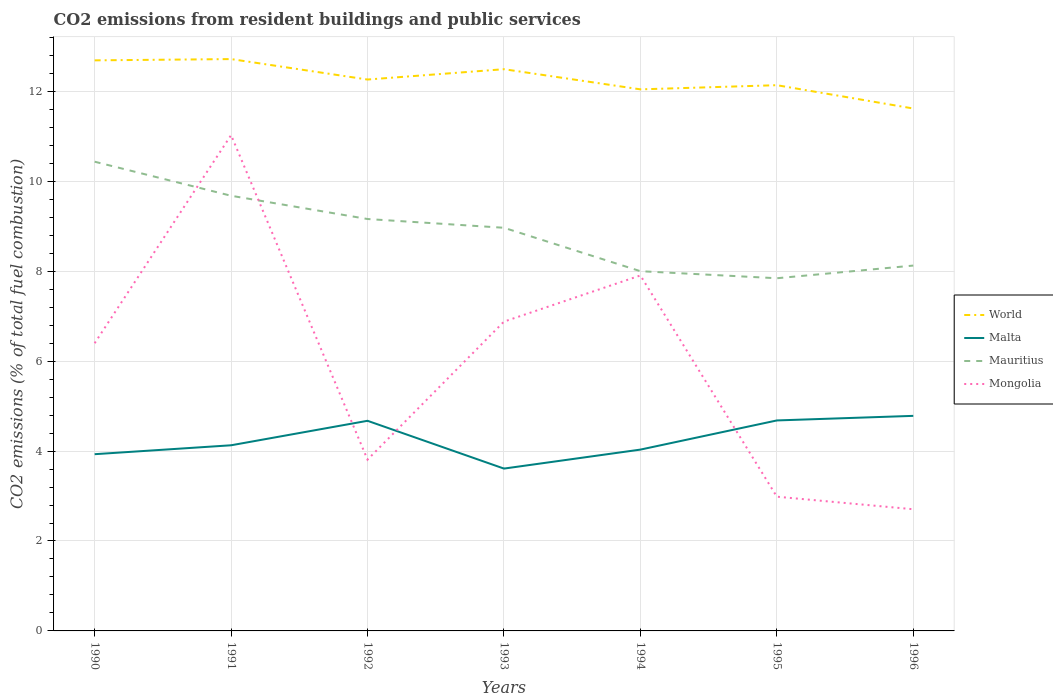Is the number of lines equal to the number of legend labels?
Your response must be concise. Yes. Across all years, what is the maximum total CO2 emitted in Mauritius?
Ensure brevity in your answer.  7.84. What is the total total CO2 emitted in Malta in the graph?
Offer a terse response. -0.01. What is the difference between the highest and the second highest total CO2 emitted in Mongolia?
Your answer should be very brief. 8.32. What is the difference between the highest and the lowest total CO2 emitted in World?
Make the answer very short. 3. Is the total CO2 emitted in Mongolia strictly greater than the total CO2 emitted in Mauritius over the years?
Your answer should be compact. No. How many years are there in the graph?
Your answer should be compact. 7. What is the difference between two consecutive major ticks on the Y-axis?
Keep it short and to the point. 2. Are the values on the major ticks of Y-axis written in scientific E-notation?
Ensure brevity in your answer.  No. Does the graph contain any zero values?
Keep it short and to the point. No. Does the graph contain grids?
Offer a very short reply. Yes. Where does the legend appear in the graph?
Keep it short and to the point. Center right. How are the legend labels stacked?
Give a very brief answer. Vertical. What is the title of the graph?
Offer a terse response. CO2 emissions from resident buildings and public services. Does "Caribbean small states" appear as one of the legend labels in the graph?
Offer a terse response. No. What is the label or title of the Y-axis?
Ensure brevity in your answer.  CO2 emissions (% of total fuel combustion). What is the CO2 emissions (% of total fuel combustion) in World in 1990?
Keep it short and to the point. 12.69. What is the CO2 emissions (% of total fuel combustion) of Malta in 1990?
Your answer should be very brief. 3.93. What is the CO2 emissions (% of total fuel combustion) of Mauritius in 1990?
Your answer should be compact. 10.43. What is the CO2 emissions (% of total fuel combustion) in Mongolia in 1990?
Offer a very short reply. 6.4. What is the CO2 emissions (% of total fuel combustion) in World in 1991?
Offer a terse response. 12.72. What is the CO2 emissions (% of total fuel combustion) in Malta in 1991?
Your answer should be very brief. 4.13. What is the CO2 emissions (% of total fuel combustion) of Mauritius in 1991?
Give a very brief answer. 9.68. What is the CO2 emissions (% of total fuel combustion) of Mongolia in 1991?
Provide a short and direct response. 11.03. What is the CO2 emissions (% of total fuel combustion) of World in 1992?
Provide a succinct answer. 12.26. What is the CO2 emissions (% of total fuel combustion) of Malta in 1992?
Give a very brief answer. 4.67. What is the CO2 emissions (% of total fuel combustion) in Mauritius in 1992?
Provide a succinct answer. 9.16. What is the CO2 emissions (% of total fuel combustion) of Mongolia in 1992?
Offer a very short reply. 3.81. What is the CO2 emissions (% of total fuel combustion) of World in 1993?
Offer a terse response. 12.49. What is the CO2 emissions (% of total fuel combustion) in Malta in 1993?
Your answer should be compact. 3.61. What is the CO2 emissions (% of total fuel combustion) in Mauritius in 1993?
Keep it short and to the point. 8.97. What is the CO2 emissions (% of total fuel combustion) in Mongolia in 1993?
Provide a short and direct response. 6.88. What is the CO2 emissions (% of total fuel combustion) of World in 1994?
Your response must be concise. 12.04. What is the CO2 emissions (% of total fuel combustion) in Malta in 1994?
Make the answer very short. 4.03. What is the CO2 emissions (% of total fuel combustion) of Mongolia in 1994?
Offer a terse response. 7.91. What is the CO2 emissions (% of total fuel combustion) of World in 1995?
Give a very brief answer. 12.14. What is the CO2 emissions (% of total fuel combustion) of Malta in 1995?
Make the answer very short. 4.68. What is the CO2 emissions (% of total fuel combustion) in Mauritius in 1995?
Give a very brief answer. 7.84. What is the CO2 emissions (% of total fuel combustion) in Mongolia in 1995?
Offer a terse response. 2.99. What is the CO2 emissions (% of total fuel combustion) of World in 1996?
Make the answer very short. 11.62. What is the CO2 emissions (% of total fuel combustion) of Malta in 1996?
Your answer should be compact. 4.78. What is the CO2 emissions (% of total fuel combustion) in Mauritius in 1996?
Offer a terse response. 8.12. What is the CO2 emissions (% of total fuel combustion) in Mongolia in 1996?
Ensure brevity in your answer.  2.71. Across all years, what is the maximum CO2 emissions (% of total fuel combustion) in World?
Your response must be concise. 12.72. Across all years, what is the maximum CO2 emissions (% of total fuel combustion) in Malta?
Offer a terse response. 4.78. Across all years, what is the maximum CO2 emissions (% of total fuel combustion) in Mauritius?
Provide a succinct answer. 10.43. Across all years, what is the maximum CO2 emissions (% of total fuel combustion) in Mongolia?
Your answer should be compact. 11.03. Across all years, what is the minimum CO2 emissions (% of total fuel combustion) in World?
Your answer should be very brief. 11.62. Across all years, what is the minimum CO2 emissions (% of total fuel combustion) of Malta?
Give a very brief answer. 3.61. Across all years, what is the minimum CO2 emissions (% of total fuel combustion) in Mauritius?
Give a very brief answer. 7.84. Across all years, what is the minimum CO2 emissions (% of total fuel combustion) in Mongolia?
Your answer should be compact. 2.71. What is the total CO2 emissions (% of total fuel combustion) in World in the graph?
Provide a short and direct response. 85.96. What is the total CO2 emissions (% of total fuel combustion) of Malta in the graph?
Provide a short and direct response. 29.84. What is the total CO2 emissions (% of total fuel combustion) in Mauritius in the graph?
Give a very brief answer. 62.21. What is the total CO2 emissions (% of total fuel combustion) in Mongolia in the graph?
Provide a short and direct response. 41.71. What is the difference between the CO2 emissions (% of total fuel combustion) in World in 1990 and that in 1991?
Offer a very short reply. -0.03. What is the difference between the CO2 emissions (% of total fuel combustion) in Malta in 1990 and that in 1991?
Offer a terse response. -0.2. What is the difference between the CO2 emissions (% of total fuel combustion) of Mauritius in 1990 and that in 1991?
Provide a succinct answer. 0.76. What is the difference between the CO2 emissions (% of total fuel combustion) of Mongolia in 1990 and that in 1991?
Keep it short and to the point. -4.63. What is the difference between the CO2 emissions (% of total fuel combustion) in World in 1990 and that in 1992?
Offer a terse response. 0.43. What is the difference between the CO2 emissions (% of total fuel combustion) in Malta in 1990 and that in 1992?
Ensure brevity in your answer.  -0.74. What is the difference between the CO2 emissions (% of total fuel combustion) of Mauritius in 1990 and that in 1992?
Your answer should be compact. 1.27. What is the difference between the CO2 emissions (% of total fuel combustion) of Mongolia in 1990 and that in 1992?
Your response must be concise. 2.59. What is the difference between the CO2 emissions (% of total fuel combustion) of World in 1990 and that in 1993?
Provide a succinct answer. 0.2. What is the difference between the CO2 emissions (% of total fuel combustion) in Malta in 1990 and that in 1993?
Your answer should be compact. 0.32. What is the difference between the CO2 emissions (% of total fuel combustion) in Mauritius in 1990 and that in 1993?
Offer a very short reply. 1.47. What is the difference between the CO2 emissions (% of total fuel combustion) of Mongolia in 1990 and that in 1993?
Your answer should be compact. -0.48. What is the difference between the CO2 emissions (% of total fuel combustion) in World in 1990 and that in 1994?
Keep it short and to the point. 0.64. What is the difference between the CO2 emissions (% of total fuel combustion) of Malta in 1990 and that in 1994?
Provide a short and direct response. -0.1. What is the difference between the CO2 emissions (% of total fuel combustion) in Mauritius in 1990 and that in 1994?
Your answer should be compact. 2.43. What is the difference between the CO2 emissions (% of total fuel combustion) of Mongolia in 1990 and that in 1994?
Keep it short and to the point. -1.51. What is the difference between the CO2 emissions (% of total fuel combustion) of World in 1990 and that in 1995?
Provide a succinct answer. 0.55. What is the difference between the CO2 emissions (% of total fuel combustion) in Malta in 1990 and that in 1995?
Offer a very short reply. -0.75. What is the difference between the CO2 emissions (% of total fuel combustion) of Mauritius in 1990 and that in 1995?
Your response must be concise. 2.59. What is the difference between the CO2 emissions (% of total fuel combustion) of Mongolia in 1990 and that in 1995?
Offer a terse response. 3.41. What is the difference between the CO2 emissions (% of total fuel combustion) in World in 1990 and that in 1996?
Provide a succinct answer. 1.07. What is the difference between the CO2 emissions (% of total fuel combustion) of Malta in 1990 and that in 1996?
Provide a short and direct response. -0.85. What is the difference between the CO2 emissions (% of total fuel combustion) of Mauritius in 1990 and that in 1996?
Offer a terse response. 2.31. What is the difference between the CO2 emissions (% of total fuel combustion) of Mongolia in 1990 and that in 1996?
Keep it short and to the point. 3.69. What is the difference between the CO2 emissions (% of total fuel combustion) of World in 1991 and that in 1992?
Give a very brief answer. 0.45. What is the difference between the CO2 emissions (% of total fuel combustion) of Malta in 1991 and that in 1992?
Offer a terse response. -0.54. What is the difference between the CO2 emissions (% of total fuel combustion) of Mauritius in 1991 and that in 1992?
Your response must be concise. 0.52. What is the difference between the CO2 emissions (% of total fuel combustion) in Mongolia in 1991 and that in 1992?
Offer a very short reply. 7.22. What is the difference between the CO2 emissions (% of total fuel combustion) in World in 1991 and that in 1993?
Your answer should be very brief. 0.23. What is the difference between the CO2 emissions (% of total fuel combustion) in Malta in 1991 and that in 1993?
Offer a terse response. 0.52. What is the difference between the CO2 emissions (% of total fuel combustion) in Mauritius in 1991 and that in 1993?
Provide a short and direct response. 0.71. What is the difference between the CO2 emissions (% of total fuel combustion) of Mongolia in 1991 and that in 1993?
Your answer should be very brief. 4.15. What is the difference between the CO2 emissions (% of total fuel combustion) in World in 1991 and that in 1994?
Offer a terse response. 0.67. What is the difference between the CO2 emissions (% of total fuel combustion) of Malta in 1991 and that in 1994?
Keep it short and to the point. 0.1. What is the difference between the CO2 emissions (% of total fuel combustion) of Mauritius in 1991 and that in 1994?
Ensure brevity in your answer.  1.68. What is the difference between the CO2 emissions (% of total fuel combustion) in Mongolia in 1991 and that in 1994?
Your answer should be compact. 3.12. What is the difference between the CO2 emissions (% of total fuel combustion) in World in 1991 and that in 1995?
Provide a short and direct response. 0.58. What is the difference between the CO2 emissions (% of total fuel combustion) of Malta in 1991 and that in 1995?
Your response must be concise. -0.55. What is the difference between the CO2 emissions (% of total fuel combustion) of Mauritius in 1991 and that in 1995?
Make the answer very short. 1.83. What is the difference between the CO2 emissions (% of total fuel combustion) in Mongolia in 1991 and that in 1995?
Ensure brevity in your answer.  8.04. What is the difference between the CO2 emissions (% of total fuel combustion) in World in 1991 and that in 1996?
Ensure brevity in your answer.  1.1. What is the difference between the CO2 emissions (% of total fuel combustion) of Malta in 1991 and that in 1996?
Provide a short and direct response. -0.65. What is the difference between the CO2 emissions (% of total fuel combustion) of Mauritius in 1991 and that in 1996?
Make the answer very short. 1.55. What is the difference between the CO2 emissions (% of total fuel combustion) of Mongolia in 1991 and that in 1996?
Give a very brief answer. 8.32. What is the difference between the CO2 emissions (% of total fuel combustion) in World in 1992 and that in 1993?
Keep it short and to the point. -0.23. What is the difference between the CO2 emissions (% of total fuel combustion) of Malta in 1992 and that in 1993?
Offer a very short reply. 1.06. What is the difference between the CO2 emissions (% of total fuel combustion) in Mauritius in 1992 and that in 1993?
Offer a very short reply. 0.19. What is the difference between the CO2 emissions (% of total fuel combustion) in Mongolia in 1992 and that in 1993?
Make the answer very short. -3.07. What is the difference between the CO2 emissions (% of total fuel combustion) of World in 1992 and that in 1994?
Give a very brief answer. 0.22. What is the difference between the CO2 emissions (% of total fuel combustion) in Malta in 1992 and that in 1994?
Provide a succinct answer. 0.64. What is the difference between the CO2 emissions (% of total fuel combustion) of Mauritius in 1992 and that in 1994?
Provide a succinct answer. 1.16. What is the difference between the CO2 emissions (% of total fuel combustion) of Mongolia in 1992 and that in 1994?
Provide a succinct answer. -4.1. What is the difference between the CO2 emissions (% of total fuel combustion) of World in 1992 and that in 1995?
Your response must be concise. 0.13. What is the difference between the CO2 emissions (% of total fuel combustion) in Malta in 1992 and that in 1995?
Offer a terse response. -0.01. What is the difference between the CO2 emissions (% of total fuel combustion) in Mauritius in 1992 and that in 1995?
Ensure brevity in your answer.  1.32. What is the difference between the CO2 emissions (% of total fuel combustion) in Mongolia in 1992 and that in 1995?
Your answer should be very brief. 0.82. What is the difference between the CO2 emissions (% of total fuel combustion) in World in 1992 and that in 1996?
Offer a terse response. 0.64. What is the difference between the CO2 emissions (% of total fuel combustion) in Malta in 1992 and that in 1996?
Give a very brief answer. -0.11. What is the difference between the CO2 emissions (% of total fuel combustion) of Mauritius in 1992 and that in 1996?
Make the answer very short. 1.04. What is the difference between the CO2 emissions (% of total fuel combustion) in Mongolia in 1992 and that in 1996?
Ensure brevity in your answer.  1.1. What is the difference between the CO2 emissions (% of total fuel combustion) in World in 1993 and that in 1994?
Offer a very short reply. 0.45. What is the difference between the CO2 emissions (% of total fuel combustion) of Malta in 1993 and that in 1994?
Keep it short and to the point. -0.42. What is the difference between the CO2 emissions (% of total fuel combustion) in Mauritius in 1993 and that in 1994?
Offer a terse response. 0.97. What is the difference between the CO2 emissions (% of total fuel combustion) of Mongolia in 1993 and that in 1994?
Offer a very short reply. -1.03. What is the difference between the CO2 emissions (% of total fuel combustion) of World in 1993 and that in 1995?
Offer a very short reply. 0.36. What is the difference between the CO2 emissions (% of total fuel combustion) in Malta in 1993 and that in 1995?
Offer a terse response. -1.07. What is the difference between the CO2 emissions (% of total fuel combustion) of Mauritius in 1993 and that in 1995?
Make the answer very short. 1.12. What is the difference between the CO2 emissions (% of total fuel combustion) of Mongolia in 1993 and that in 1995?
Give a very brief answer. 3.89. What is the difference between the CO2 emissions (% of total fuel combustion) in World in 1993 and that in 1996?
Keep it short and to the point. 0.87. What is the difference between the CO2 emissions (% of total fuel combustion) in Malta in 1993 and that in 1996?
Your answer should be compact. -1.17. What is the difference between the CO2 emissions (% of total fuel combustion) of Mauritius in 1993 and that in 1996?
Your response must be concise. 0.84. What is the difference between the CO2 emissions (% of total fuel combustion) in Mongolia in 1993 and that in 1996?
Provide a succinct answer. 4.17. What is the difference between the CO2 emissions (% of total fuel combustion) of World in 1994 and that in 1995?
Your answer should be very brief. -0.09. What is the difference between the CO2 emissions (% of total fuel combustion) in Malta in 1994 and that in 1995?
Provide a succinct answer. -0.65. What is the difference between the CO2 emissions (% of total fuel combustion) of Mauritius in 1994 and that in 1995?
Keep it short and to the point. 0.16. What is the difference between the CO2 emissions (% of total fuel combustion) of Mongolia in 1994 and that in 1995?
Your response must be concise. 4.92. What is the difference between the CO2 emissions (% of total fuel combustion) in World in 1994 and that in 1996?
Make the answer very short. 0.43. What is the difference between the CO2 emissions (% of total fuel combustion) of Malta in 1994 and that in 1996?
Make the answer very short. -0.75. What is the difference between the CO2 emissions (% of total fuel combustion) in Mauritius in 1994 and that in 1996?
Make the answer very short. -0.12. What is the difference between the CO2 emissions (% of total fuel combustion) in Mongolia in 1994 and that in 1996?
Offer a very short reply. 5.2. What is the difference between the CO2 emissions (% of total fuel combustion) of World in 1995 and that in 1996?
Your answer should be compact. 0.52. What is the difference between the CO2 emissions (% of total fuel combustion) of Malta in 1995 and that in 1996?
Your response must be concise. -0.1. What is the difference between the CO2 emissions (% of total fuel combustion) of Mauritius in 1995 and that in 1996?
Your answer should be compact. -0.28. What is the difference between the CO2 emissions (% of total fuel combustion) in Mongolia in 1995 and that in 1996?
Your answer should be compact. 0.28. What is the difference between the CO2 emissions (% of total fuel combustion) in World in 1990 and the CO2 emissions (% of total fuel combustion) in Malta in 1991?
Make the answer very short. 8.56. What is the difference between the CO2 emissions (% of total fuel combustion) in World in 1990 and the CO2 emissions (% of total fuel combustion) in Mauritius in 1991?
Offer a very short reply. 3.01. What is the difference between the CO2 emissions (% of total fuel combustion) in World in 1990 and the CO2 emissions (% of total fuel combustion) in Mongolia in 1991?
Offer a very short reply. 1.66. What is the difference between the CO2 emissions (% of total fuel combustion) in Malta in 1990 and the CO2 emissions (% of total fuel combustion) in Mauritius in 1991?
Offer a terse response. -5.75. What is the difference between the CO2 emissions (% of total fuel combustion) in Malta in 1990 and the CO2 emissions (% of total fuel combustion) in Mongolia in 1991?
Offer a very short reply. -7.1. What is the difference between the CO2 emissions (% of total fuel combustion) in Mauritius in 1990 and the CO2 emissions (% of total fuel combustion) in Mongolia in 1991?
Provide a succinct answer. -0.59. What is the difference between the CO2 emissions (% of total fuel combustion) in World in 1990 and the CO2 emissions (% of total fuel combustion) in Malta in 1992?
Keep it short and to the point. 8.02. What is the difference between the CO2 emissions (% of total fuel combustion) in World in 1990 and the CO2 emissions (% of total fuel combustion) in Mauritius in 1992?
Your response must be concise. 3.53. What is the difference between the CO2 emissions (% of total fuel combustion) of World in 1990 and the CO2 emissions (% of total fuel combustion) of Mongolia in 1992?
Keep it short and to the point. 8.88. What is the difference between the CO2 emissions (% of total fuel combustion) of Malta in 1990 and the CO2 emissions (% of total fuel combustion) of Mauritius in 1992?
Your response must be concise. -5.23. What is the difference between the CO2 emissions (% of total fuel combustion) of Malta in 1990 and the CO2 emissions (% of total fuel combustion) of Mongolia in 1992?
Your answer should be compact. 0.12. What is the difference between the CO2 emissions (% of total fuel combustion) of Mauritius in 1990 and the CO2 emissions (% of total fuel combustion) of Mongolia in 1992?
Provide a short and direct response. 6.63. What is the difference between the CO2 emissions (% of total fuel combustion) in World in 1990 and the CO2 emissions (% of total fuel combustion) in Malta in 1993?
Your response must be concise. 9.08. What is the difference between the CO2 emissions (% of total fuel combustion) of World in 1990 and the CO2 emissions (% of total fuel combustion) of Mauritius in 1993?
Give a very brief answer. 3.72. What is the difference between the CO2 emissions (% of total fuel combustion) of World in 1990 and the CO2 emissions (% of total fuel combustion) of Mongolia in 1993?
Your answer should be very brief. 5.81. What is the difference between the CO2 emissions (% of total fuel combustion) of Malta in 1990 and the CO2 emissions (% of total fuel combustion) of Mauritius in 1993?
Your answer should be very brief. -5.04. What is the difference between the CO2 emissions (% of total fuel combustion) in Malta in 1990 and the CO2 emissions (% of total fuel combustion) in Mongolia in 1993?
Make the answer very short. -2.95. What is the difference between the CO2 emissions (% of total fuel combustion) in Mauritius in 1990 and the CO2 emissions (% of total fuel combustion) in Mongolia in 1993?
Offer a terse response. 3.56. What is the difference between the CO2 emissions (% of total fuel combustion) of World in 1990 and the CO2 emissions (% of total fuel combustion) of Malta in 1994?
Provide a succinct answer. 8.66. What is the difference between the CO2 emissions (% of total fuel combustion) of World in 1990 and the CO2 emissions (% of total fuel combustion) of Mauritius in 1994?
Provide a succinct answer. 4.69. What is the difference between the CO2 emissions (% of total fuel combustion) in World in 1990 and the CO2 emissions (% of total fuel combustion) in Mongolia in 1994?
Make the answer very short. 4.78. What is the difference between the CO2 emissions (% of total fuel combustion) in Malta in 1990 and the CO2 emissions (% of total fuel combustion) in Mauritius in 1994?
Your answer should be very brief. -4.07. What is the difference between the CO2 emissions (% of total fuel combustion) of Malta in 1990 and the CO2 emissions (% of total fuel combustion) of Mongolia in 1994?
Make the answer very short. -3.98. What is the difference between the CO2 emissions (% of total fuel combustion) of Mauritius in 1990 and the CO2 emissions (% of total fuel combustion) of Mongolia in 1994?
Ensure brevity in your answer.  2.53. What is the difference between the CO2 emissions (% of total fuel combustion) in World in 1990 and the CO2 emissions (% of total fuel combustion) in Malta in 1995?
Your response must be concise. 8.01. What is the difference between the CO2 emissions (% of total fuel combustion) of World in 1990 and the CO2 emissions (% of total fuel combustion) of Mauritius in 1995?
Your answer should be compact. 4.85. What is the difference between the CO2 emissions (% of total fuel combustion) in World in 1990 and the CO2 emissions (% of total fuel combustion) in Mongolia in 1995?
Offer a very short reply. 9.7. What is the difference between the CO2 emissions (% of total fuel combustion) in Malta in 1990 and the CO2 emissions (% of total fuel combustion) in Mauritius in 1995?
Provide a short and direct response. -3.91. What is the difference between the CO2 emissions (% of total fuel combustion) in Malta in 1990 and the CO2 emissions (% of total fuel combustion) in Mongolia in 1995?
Offer a terse response. 0.95. What is the difference between the CO2 emissions (% of total fuel combustion) in Mauritius in 1990 and the CO2 emissions (% of total fuel combustion) in Mongolia in 1995?
Offer a terse response. 7.45. What is the difference between the CO2 emissions (% of total fuel combustion) of World in 1990 and the CO2 emissions (% of total fuel combustion) of Malta in 1996?
Provide a succinct answer. 7.91. What is the difference between the CO2 emissions (% of total fuel combustion) of World in 1990 and the CO2 emissions (% of total fuel combustion) of Mauritius in 1996?
Your answer should be compact. 4.56. What is the difference between the CO2 emissions (% of total fuel combustion) of World in 1990 and the CO2 emissions (% of total fuel combustion) of Mongolia in 1996?
Make the answer very short. 9.98. What is the difference between the CO2 emissions (% of total fuel combustion) of Malta in 1990 and the CO2 emissions (% of total fuel combustion) of Mauritius in 1996?
Provide a short and direct response. -4.19. What is the difference between the CO2 emissions (% of total fuel combustion) of Malta in 1990 and the CO2 emissions (% of total fuel combustion) of Mongolia in 1996?
Keep it short and to the point. 1.22. What is the difference between the CO2 emissions (% of total fuel combustion) of Mauritius in 1990 and the CO2 emissions (% of total fuel combustion) of Mongolia in 1996?
Ensure brevity in your answer.  7.73. What is the difference between the CO2 emissions (% of total fuel combustion) in World in 1991 and the CO2 emissions (% of total fuel combustion) in Malta in 1992?
Keep it short and to the point. 8.04. What is the difference between the CO2 emissions (% of total fuel combustion) of World in 1991 and the CO2 emissions (% of total fuel combustion) of Mauritius in 1992?
Ensure brevity in your answer.  3.56. What is the difference between the CO2 emissions (% of total fuel combustion) in World in 1991 and the CO2 emissions (% of total fuel combustion) in Mongolia in 1992?
Offer a terse response. 8.91. What is the difference between the CO2 emissions (% of total fuel combustion) in Malta in 1991 and the CO2 emissions (% of total fuel combustion) in Mauritius in 1992?
Ensure brevity in your answer.  -5.03. What is the difference between the CO2 emissions (% of total fuel combustion) of Malta in 1991 and the CO2 emissions (% of total fuel combustion) of Mongolia in 1992?
Offer a very short reply. 0.32. What is the difference between the CO2 emissions (% of total fuel combustion) of Mauritius in 1991 and the CO2 emissions (% of total fuel combustion) of Mongolia in 1992?
Give a very brief answer. 5.87. What is the difference between the CO2 emissions (% of total fuel combustion) in World in 1991 and the CO2 emissions (% of total fuel combustion) in Malta in 1993?
Offer a very short reply. 9.11. What is the difference between the CO2 emissions (% of total fuel combustion) in World in 1991 and the CO2 emissions (% of total fuel combustion) in Mauritius in 1993?
Offer a very short reply. 3.75. What is the difference between the CO2 emissions (% of total fuel combustion) of World in 1991 and the CO2 emissions (% of total fuel combustion) of Mongolia in 1993?
Your response must be concise. 5.84. What is the difference between the CO2 emissions (% of total fuel combustion) in Malta in 1991 and the CO2 emissions (% of total fuel combustion) in Mauritius in 1993?
Provide a succinct answer. -4.84. What is the difference between the CO2 emissions (% of total fuel combustion) of Malta in 1991 and the CO2 emissions (% of total fuel combustion) of Mongolia in 1993?
Offer a terse response. -2.75. What is the difference between the CO2 emissions (% of total fuel combustion) in Mauritius in 1991 and the CO2 emissions (% of total fuel combustion) in Mongolia in 1993?
Your answer should be compact. 2.8. What is the difference between the CO2 emissions (% of total fuel combustion) of World in 1991 and the CO2 emissions (% of total fuel combustion) of Malta in 1994?
Keep it short and to the point. 8.68. What is the difference between the CO2 emissions (% of total fuel combustion) in World in 1991 and the CO2 emissions (% of total fuel combustion) in Mauritius in 1994?
Your response must be concise. 4.72. What is the difference between the CO2 emissions (% of total fuel combustion) in World in 1991 and the CO2 emissions (% of total fuel combustion) in Mongolia in 1994?
Ensure brevity in your answer.  4.81. What is the difference between the CO2 emissions (% of total fuel combustion) of Malta in 1991 and the CO2 emissions (% of total fuel combustion) of Mauritius in 1994?
Your answer should be compact. -3.87. What is the difference between the CO2 emissions (% of total fuel combustion) of Malta in 1991 and the CO2 emissions (% of total fuel combustion) of Mongolia in 1994?
Make the answer very short. -3.78. What is the difference between the CO2 emissions (% of total fuel combustion) of Mauritius in 1991 and the CO2 emissions (% of total fuel combustion) of Mongolia in 1994?
Give a very brief answer. 1.77. What is the difference between the CO2 emissions (% of total fuel combustion) of World in 1991 and the CO2 emissions (% of total fuel combustion) of Malta in 1995?
Your response must be concise. 8.04. What is the difference between the CO2 emissions (% of total fuel combustion) in World in 1991 and the CO2 emissions (% of total fuel combustion) in Mauritius in 1995?
Your response must be concise. 4.87. What is the difference between the CO2 emissions (% of total fuel combustion) in World in 1991 and the CO2 emissions (% of total fuel combustion) in Mongolia in 1995?
Keep it short and to the point. 9.73. What is the difference between the CO2 emissions (% of total fuel combustion) in Malta in 1991 and the CO2 emissions (% of total fuel combustion) in Mauritius in 1995?
Ensure brevity in your answer.  -3.71. What is the difference between the CO2 emissions (% of total fuel combustion) in Malta in 1991 and the CO2 emissions (% of total fuel combustion) in Mongolia in 1995?
Provide a short and direct response. 1.14. What is the difference between the CO2 emissions (% of total fuel combustion) of Mauritius in 1991 and the CO2 emissions (% of total fuel combustion) of Mongolia in 1995?
Provide a succinct answer. 6.69. What is the difference between the CO2 emissions (% of total fuel combustion) in World in 1991 and the CO2 emissions (% of total fuel combustion) in Malta in 1996?
Provide a short and direct response. 7.93. What is the difference between the CO2 emissions (% of total fuel combustion) in World in 1991 and the CO2 emissions (% of total fuel combustion) in Mauritius in 1996?
Ensure brevity in your answer.  4.59. What is the difference between the CO2 emissions (% of total fuel combustion) of World in 1991 and the CO2 emissions (% of total fuel combustion) of Mongolia in 1996?
Your answer should be compact. 10.01. What is the difference between the CO2 emissions (% of total fuel combustion) of Malta in 1991 and the CO2 emissions (% of total fuel combustion) of Mauritius in 1996?
Offer a very short reply. -4. What is the difference between the CO2 emissions (% of total fuel combustion) in Malta in 1991 and the CO2 emissions (% of total fuel combustion) in Mongolia in 1996?
Make the answer very short. 1.42. What is the difference between the CO2 emissions (% of total fuel combustion) in Mauritius in 1991 and the CO2 emissions (% of total fuel combustion) in Mongolia in 1996?
Keep it short and to the point. 6.97. What is the difference between the CO2 emissions (% of total fuel combustion) of World in 1992 and the CO2 emissions (% of total fuel combustion) of Malta in 1993?
Ensure brevity in your answer.  8.65. What is the difference between the CO2 emissions (% of total fuel combustion) of World in 1992 and the CO2 emissions (% of total fuel combustion) of Mauritius in 1993?
Offer a terse response. 3.3. What is the difference between the CO2 emissions (% of total fuel combustion) in World in 1992 and the CO2 emissions (% of total fuel combustion) in Mongolia in 1993?
Give a very brief answer. 5.38. What is the difference between the CO2 emissions (% of total fuel combustion) of Malta in 1992 and the CO2 emissions (% of total fuel combustion) of Mauritius in 1993?
Keep it short and to the point. -4.29. What is the difference between the CO2 emissions (% of total fuel combustion) of Malta in 1992 and the CO2 emissions (% of total fuel combustion) of Mongolia in 1993?
Keep it short and to the point. -2.21. What is the difference between the CO2 emissions (% of total fuel combustion) in Mauritius in 1992 and the CO2 emissions (% of total fuel combustion) in Mongolia in 1993?
Your answer should be very brief. 2.28. What is the difference between the CO2 emissions (% of total fuel combustion) of World in 1992 and the CO2 emissions (% of total fuel combustion) of Malta in 1994?
Make the answer very short. 8.23. What is the difference between the CO2 emissions (% of total fuel combustion) of World in 1992 and the CO2 emissions (% of total fuel combustion) of Mauritius in 1994?
Make the answer very short. 4.26. What is the difference between the CO2 emissions (% of total fuel combustion) of World in 1992 and the CO2 emissions (% of total fuel combustion) of Mongolia in 1994?
Your response must be concise. 4.36. What is the difference between the CO2 emissions (% of total fuel combustion) in Malta in 1992 and the CO2 emissions (% of total fuel combustion) in Mauritius in 1994?
Your answer should be very brief. -3.33. What is the difference between the CO2 emissions (% of total fuel combustion) of Malta in 1992 and the CO2 emissions (% of total fuel combustion) of Mongolia in 1994?
Offer a terse response. -3.23. What is the difference between the CO2 emissions (% of total fuel combustion) of Mauritius in 1992 and the CO2 emissions (% of total fuel combustion) of Mongolia in 1994?
Your answer should be compact. 1.26. What is the difference between the CO2 emissions (% of total fuel combustion) in World in 1992 and the CO2 emissions (% of total fuel combustion) in Malta in 1995?
Offer a terse response. 7.58. What is the difference between the CO2 emissions (% of total fuel combustion) in World in 1992 and the CO2 emissions (% of total fuel combustion) in Mauritius in 1995?
Your response must be concise. 4.42. What is the difference between the CO2 emissions (% of total fuel combustion) of World in 1992 and the CO2 emissions (% of total fuel combustion) of Mongolia in 1995?
Make the answer very short. 9.28. What is the difference between the CO2 emissions (% of total fuel combustion) of Malta in 1992 and the CO2 emissions (% of total fuel combustion) of Mauritius in 1995?
Offer a very short reply. -3.17. What is the difference between the CO2 emissions (% of total fuel combustion) of Malta in 1992 and the CO2 emissions (% of total fuel combustion) of Mongolia in 1995?
Keep it short and to the point. 1.69. What is the difference between the CO2 emissions (% of total fuel combustion) in Mauritius in 1992 and the CO2 emissions (% of total fuel combustion) in Mongolia in 1995?
Provide a succinct answer. 6.18. What is the difference between the CO2 emissions (% of total fuel combustion) in World in 1992 and the CO2 emissions (% of total fuel combustion) in Malta in 1996?
Make the answer very short. 7.48. What is the difference between the CO2 emissions (% of total fuel combustion) in World in 1992 and the CO2 emissions (% of total fuel combustion) in Mauritius in 1996?
Provide a succinct answer. 4.14. What is the difference between the CO2 emissions (% of total fuel combustion) in World in 1992 and the CO2 emissions (% of total fuel combustion) in Mongolia in 1996?
Offer a very short reply. 9.56. What is the difference between the CO2 emissions (% of total fuel combustion) of Malta in 1992 and the CO2 emissions (% of total fuel combustion) of Mauritius in 1996?
Provide a short and direct response. -3.45. What is the difference between the CO2 emissions (% of total fuel combustion) in Malta in 1992 and the CO2 emissions (% of total fuel combustion) in Mongolia in 1996?
Ensure brevity in your answer.  1.97. What is the difference between the CO2 emissions (% of total fuel combustion) of Mauritius in 1992 and the CO2 emissions (% of total fuel combustion) of Mongolia in 1996?
Offer a terse response. 6.45. What is the difference between the CO2 emissions (% of total fuel combustion) of World in 1993 and the CO2 emissions (% of total fuel combustion) of Malta in 1994?
Make the answer very short. 8.46. What is the difference between the CO2 emissions (% of total fuel combustion) of World in 1993 and the CO2 emissions (% of total fuel combustion) of Mauritius in 1994?
Give a very brief answer. 4.49. What is the difference between the CO2 emissions (% of total fuel combustion) in World in 1993 and the CO2 emissions (% of total fuel combustion) in Mongolia in 1994?
Offer a very short reply. 4.59. What is the difference between the CO2 emissions (% of total fuel combustion) of Malta in 1993 and the CO2 emissions (% of total fuel combustion) of Mauritius in 1994?
Ensure brevity in your answer.  -4.39. What is the difference between the CO2 emissions (% of total fuel combustion) in Malta in 1993 and the CO2 emissions (% of total fuel combustion) in Mongolia in 1994?
Give a very brief answer. -4.29. What is the difference between the CO2 emissions (% of total fuel combustion) of Mauritius in 1993 and the CO2 emissions (% of total fuel combustion) of Mongolia in 1994?
Offer a very short reply. 1.06. What is the difference between the CO2 emissions (% of total fuel combustion) in World in 1993 and the CO2 emissions (% of total fuel combustion) in Malta in 1995?
Offer a terse response. 7.81. What is the difference between the CO2 emissions (% of total fuel combustion) of World in 1993 and the CO2 emissions (% of total fuel combustion) of Mauritius in 1995?
Provide a succinct answer. 4.65. What is the difference between the CO2 emissions (% of total fuel combustion) of World in 1993 and the CO2 emissions (% of total fuel combustion) of Mongolia in 1995?
Ensure brevity in your answer.  9.51. What is the difference between the CO2 emissions (% of total fuel combustion) of Malta in 1993 and the CO2 emissions (% of total fuel combustion) of Mauritius in 1995?
Give a very brief answer. -4.23. What is the difference between the CO2 emissions (% of total fuel combustion) of Malta in 1993 and the CO2 emissions (% of total fuel combustion) of Mongolia in 1995?
Ensure brevity in your answer.  0.62. What is the difference between the CO2 emissions (% of total fuel combustion) of Mauritius in 1993 and the CO2 emissions (% of total fuel combustion) of Mongolia in 1995?
Make the answer very short. 5.98. What is the difference between the CO2 emissions (% of total fuel combustion) of World in 1993 and the CO2 emissions (% of total fuel combustion) of Malta in 1996?
Provide a short and direct response. 7.71. What is the difference between the CO2 emissions (% of total fuel combustion) of World in 1993 and the CO2 emissions (% of total fuel combustion) of Mauritius in 1996?
Your answer should be very brief. 4.37. What is the difference between the CO2 emissions (% of total fuel combustion) in World in 1993 and the CO2 emissions (% of total fuel combustion) in Mongolia in 1996?
Your answer should be very brief. 9.79. What is the difference between the CO2 emissions (% of total fuel combustion) in Malta in 1993 and the CO2 emissions (% of total fuel combustion) in Mauritius in 1996?
Give a very brief answer. -4.51. What is the difference between the CO2 emissions (% of total fuel combustion) in Malta in 1993 and the CO2 emissions (% of total fuel combustion) in Mongolia in 1996?
Your answer should be very brief. 0.9. What is the difference between the CO2 emissions (% of total fuel combustion) in Mauritius in 1993 and the CO2 emissions (% of total fuel combustion) in Mongolia in 1996?
Give a very brief answer. 6.26. What is the difference between the CO2 emissions (% of total fuel combustion) in World in 1994 and the CO2 emissions (% of total fuel combustion) in Malta in 1995?
Make the answer very short. 7.36. What is the difference between the CO2 emissions (% of total fuel combustion) of World in 1994 and the CO2 emissions (% of total fuel combustion) of Mauritius in 1995?
Offer a terse response. 4.2. What is the difference between the CO2 emissions (% of total fuel combustion) of World in 1994 and the CO2 emissions (% of total fuel combustion) of Mongolia in 1995?
Provide a succinct answer. 9.06. What is the difference between the CO2 emissions (% of total fuel combustion) in Malta in 1994 and the CO2 emissions (% of total fuel combustion) in Mauritius in 1995?
Your answer should be compact. -3.81. What is the difference between the CO2 emissions (% of total fuel combustion) in Malta in 1994 and the CO2 emissions (% of total fuel combustion) in Mongolia in 1995?
Your answer should be compact. 1.05. What is the difference between the CO2 emissions (% of total fuel combustion) of Mauritius in 1994 and the CO2 emissions (% of total fuel combustion) of Mongolia in 1995?
Your answer should be compact. 5.01. What is the difference between the CO2 emissions (% of total fuel combustion) of World in 1994 and the CO2 emissions (% of total fuel combustion) of Malta in 1996?
Your answer should be compact. 7.26. What is the difference between the CO2 emissions (% of total fuel combustion) in World in 1994 and the CO2 emissions (% of total fuel combustion) in Mauritius in 1996?
Provide a succinct answer. 3.92. What is the difference between the CO2 emissions (% of total fuel combustion) in World in 1994 and the CO2 emissions (% of total fuel combustion) in Mongolia in 1996?
Make the answer very short. 9.34. What is the difference between the CO2 emissions (% of total fuel combustion) of Malta in 1994 and the CO2 emissions (% of total fuel combustion) of Mauritius in 1996?
Give a very brief answer. -4.09. What is the difference between the CO2 emissions (% of total fuel combustion) of Malta in 1994 and the CO2 emissions (% of total fuel combustion) of Mongolia in 1996?
Provide a succinct answer. 1.33. What is the difference between the CO2 emissions (% of total fuel combustion) in Mauritius in 1994 and the CO2 emissions (% of total fuel combustion) in Mongolia in 1996?
Your response must be concise. 5.29. What is the difference between the CO2 emissions (% of total fuel combustion) of World in 1995 and the CO2 emissions (% of total fuel combustion) of Malta in 1996?
Your answer should be compact. 7.35. What is the difference between the CO2 emissions (% of total fuel combustion) of World in 1995 and the CO2 emissions (% of total fuel combustion) of Mauritius in 1996?
Ensure brevity in your answer.  4.01. What is the difference between the CO2 emissions (% of total fuel combustion) in World in 1995 and the CO2 emissions (% of total fuel combustion) in Mongolia in 1996?
Provide a succinct answer. 9.43. What is the difference between the CO2 emissions (% of total fuel combustion) in Malta in 1995 and the CO2 emissions (% of total fuel combustion) in Mauritius in 1996?
Your answer should be very brief. -3.44. What is the difference between the CO2 emissions (% of total fuel combustion) in Malta in 1995 and the CO2 emissions (% of total fuel combustion) in Mongolia in 1996?
Provide a succinct answer. 1.98. What is the difference between the CO2 emissions (% of total fuel combustion) in Mauritius in 1995 and the CO2 emissions (% of total fuel combustion) in Mongolia in 1996?
Your answer should be very brief. 5.14. What is the average CO2 emissions (% of total fuel combustion) in World per year?
Provide a short and direct response. 12.28. What is the average CO2 emissions (% of total fuel combustion) of Malta per year?
Give a very brief answer. 4.26. What is the average CO2 emissions (% of total fuel combustion) of Mauritius per year?
Make the answer very short. 8.89. What is the average CO2 emissions (% of total fuel combustion) of Mongolia per year?
Keep it short and to the point. 5.96. In the year 1990, what is the difference between the CO2 emissions (% of total fuel combustion) of World and CO2 emissions (% of total fuel combustion) of Malta?
Provide a succinct answer. 8.76. In the year 1990, what is the difference between the CO2 emissions (% of total fuel combustion) of World and CO2 emissions (% of total fuel combustion) of Mauritius?
Keep it short and to the point. 2.25. In the year 1990, what is the difference between the CO2 emissions (% of total fuel combustion) of World and CO2 emissions (% of total fuel combustion) of Mongolia?
Give a very brief answer. 6.29. In the year 1990, what is the difference between the CO2 emissions (% of total fuel combustion) of Malta and CO2 emissions (% of total fuel combustion) of Mauritius?
Ensure brevity in your answer.  -6.5. In the year 1990, what is the difference between the CO2 emissions (% of total fuel combustion) in Malta and CO2 emissions (% of total fuel combustion) in Mongolia?
Your answer should be very brief. -2.47. In the year 1990, what is the difference between the CO2 emissions (% of total fuel combustion) of Mauritius and CO2 emissions (% of total fuel combustion) of Mongolia?
Provide a short and direct response. 4.04. In the year 1991, what is the difference between the CO2 emissions (% of total fuel combustion) in World and CO2 emissions (% of total fuel combustion) in Malta?
Keep it short and to the point. 8.59. In the year 1991, what is the difference between the CO2 emissions (% of total fuel combustion) in World and CO2 emissions (% of total fuel combustion) in Mauritius?
Give a very brief answer. 3.04. In the year 1991, what is the difference between the CO2 emissions (% of total fuel combustion) in World and CO2 emissions (% of total fuel combustion) in Mongolia?
Offer a terse response. 1.69. In the year 1991, what is the difference between the CO2 emissions (% of total fuel combustion) of Malta and CO2 emissions (% of total fuel combustion) of Mauritius?
Your answer should be compact. -5.55. In the year 1991, what is the difference between the CO2 emissions (% of total fuel combustion) of Malta and CO2 emissions (% of total fuel combustion) of Mongolia?
Your answer should be very brief. -6.9. In the year 1991, what is the difference between the CO2 emissions (% of total fuel combustion) in Mauritius and CO2 emissions (% of total fuel combustion) in Mongolia?
Give a very brief answer. -1.35. In the year 1992, what is the difference between the CO2 emissions (% of total fuel combustion) in World and CO2 emissions (% of total fuel combustion) in Malta?
Offer a terse response. 7.59. In the year 1992, what is the difference between the CO2 emissions (% of total fuel combustion) in World and CO2 emissions (% of total fuel combustion) in Mauritius?
Offer a very short reply. 3.1. In the year 1992, what is the difference between the CO2 emissions (% of total fuel combustion) in World and CO2 emissions (% of total fuel combustion) in Mongolia?
Give a very brief answer. 8.45. In the year 1992, what is the difference between the CO2 emissions (% of total fuel combustion) of Malta and CO2 emissions (% of total fuel combustion) of Mauritius?
Ensure brevity in your answer.  -4.49. In the year 1992, what is the difference between the CO2 emissions (% of total fuel combustion) in Malta and CO2 emissions (% of total fuel combustion) in Mongolia?
Your answer should be compact. 0.86. In the year 1992, what is the difference between the CO2 emissions (% of total fuel combustion) in Mauritius and CO2 emissions (% of total fuel combustion) in Mongolia?
Your response must be concise. 5.35. In the year 1993, what is the difference between the CO2 emissions (% of total fuel combustion) in World and CO2 emissions (% of total fuel combustion) in Malta?
Offer a terse response. 8.88. In the year 1993, what is the difference between the CO2 emissions (% of total fuel combustion) in World and CO2 emissions (% of total fuel combustion) in Mauritius?
Your answer should be compact. 3.53. In the year 1993, what is the difference between the CO2 emissions (% of total fuel combustion) in World and CO2 emissions (% of total fuel combustion) in Mongolia?
Provide a succinct answer. 5.61. In the year 1993, what is the difference between the CO2 emissions (% of total fuel combustion) in Malta and CO2 emissions (% of total fuel combustion) in Mauritius?
Keep it short and to the point. -5.36. In the year 1993, what is the difference between the CO2 emissions (% of total fuel combustion) of Malta and CO2 emissions (% of total fuel combustion) of Mongolia?
Your answer should be very brief. -3.27. In the year 1993, what is the difference between the CO2 emissions (% of total fuel combustion) of Mauritius and CO2 emissions (% of total fuel combustion) of Mongolia?
Offer a terse response. 2.09. In the year 1994, what is the difference between the CO2 emissions (% of total fuel combustion) in World and CO2 emissions (% of total fuel combustion) in Malta?
Offer a terse response. 8.01. In the year 1994, what is the difference between the CO2 emissions (% of total fuel combustion) of World and CO2 emissions (% of total fuel combustion) of Mauritius?
Your answer should be compact. 4.04. In the year 1994, what is the difference between the CO2 emissions (% of total fuel combustion) of World and CO2 emissions (% of total fuel combustion) of Mongolia?
Keep it short and to the point. 4.14. In the year 1994, what is the difference between the CO2 emissions (% of total fuel combustion) of Malta and CO2 emissions (% of total fuel combustion) of Mauritius?
Make the answer very short. -3.97. In the year 1994, what is the difference between the CO2 emissions (% of total fuel combustion) of Malta and CO2 emissions (% of total fuel combustion) of Mongolia?
Provide a succinct answer. -3.87. In the year 1994, what is the difference between the CO2 emissions (% of total fuel combustion) of Mauritius and CO2 emissions (% of total fuel combustion) of Mongolia?
Offer a terse response. 0.09. In the year 1995, what is the difference between the CO2 emissions (% of total fuel combustion) of World and CO2 emissions (% of total fuel combustion) of Malta?
Offer a very short reply. 7.46. In the year 1995, what is the difference between the CO2 emissions (% of total fuel combustion) in World and CO2 emissions (% of total fuel combustion) in Mauritius?
Offer a very short reply. 4.29. In the year 1995, what is the difference between the CO2 emissions (% of total fuel combustion) in World and CO2 emissions (% of total fuel combustion) in Mongolia?
Provide a short and direct response. 9.15. In the year 1995, what is the difference between the CO2 emissions (% of total fuel combustion) of Malta and CO2 emissions (% of total fuel combustion) of Mauritius?
Ensure brevity in your answer.  -3.16. In the year 1995, what is the difference between the CO2 emissions (% of total fuel combustion) of Malta and CO2 emissions (% of total fuel combustion) of Mongolia?
Keep it short and to the point. 1.7. In the year 1995, what is the difference between the CO2 emissions (% of total fuel combustion) of Mauritius and CO2 emissions (% of total fuel combustion) of Mongolia?
Keep it short and to the point. 4.86. In the year 1996, what is the difference between the CO2 emissions (% of total fuel combustion) in World and CO2 emissions (% of total fuel combustion) in Malta?
Provide a succinct answer. 6.84. In the year 1996, what is the difference between the CO2 emissions (% of total fuel combustion) in World and CO2 emissions (% of total fuel combustion) in Mauritius?
Make the answer very short. 3.49. In the year 1996, what is the difference between the CO2 emissions (% of total fuel combustion) in World and CO2 emissions (% of total fuel combustion) in Mongolia?
Offer a very short reply. 8.91. In the year 1996, what is the difference between the CO2 emissions (% of total fuel combustion) in Malta and CO2 emissions (% of total fuel combustion) in Mauritius?
Give a very brief answer. -3.34. In the year 1996, what is the difference between the CO2 emissions (% of total fuel combustion) of Malta and CO2 emissions (% of total fuel combustion) of Mongolia?
Give a very brief answer. 2.08. In the year 1996, what is the difference between the CO2 emissions (% of total fuel combustion) in Mauritius and CO2 emissions (% of total fuel combustion) in Mongolia?
Your response must be concise. 5.42. What is the ratio of the CO2 emissions (% of total fuel combustion) of Mauritius in 1990 to that in 1991?
Provide a short and direct response. 1.08. What is the ratio of the CO2 emissions (% of total fuel combustion) in Mongolia in 1990 to that in 1991?
Your answer should be compact. 0.58. What is the ratio of the CO2 emissions (% of total fuel combustion) in World in 1990 to that in 1992?
Provide a succinct answer. 1.03. What is the ratio of the CO2 emissions (% of total fuel combustion) of Malta in 1990 to that in 1992?
Make the answer very short. 0.84. What is the ratio of the CO2 emissions (% of total fuel combustion) of Mauritius in 1990 to that in 1992?
Make the answer very short. 1.14. What is the ratio of the CO2 emissions (% of total fuel combustion) of Mongolia in 1990 to that in 1992?
Your answer should be compact. 1.68. What is the ratio of the CO2 emissions (% of total fuel combustion) in World in 1990 to that in 1993?
Make the answer very short. 1.02. What is the ratio of the CO2 emissions (% of total fuel combustion) of Malta in 1990 to that in 1993?
Your answer should be very brief. 1.09. What is the ratio of the CO2 emissions (% of total fuel combustion) in Mauritius in 1990 to that in 1993?
Make the answer very short. 1.16. What is the ratio of the CO2 emissions (% of total fuel combustion) of Mongolia in 1990 to that in 1993?
Give a very brief answer. 0.93. What is the ratio of the CO2 emissions (% of total fuel combustion) in World in 1990 to that in 1994?
Your answer should be compact. 1.05. What is the ratio of the CO2 emissions (% of total fuel combustion) in Malta in 1990 to that in 1994?
Provide a succinct answer. 0.97. What is the ratio of the CO2 emissions (% of total fuel combustion) in Mauritius in 1990 to that in 1994?
Give a very brief answer. 1.3. What is the ratio of the CO2 emissions (% of total fuel combustion) of Mongolia in 1990 to that in 1994?
Provide a succinct answer. 0.81. What is the ratio of the CO2 emissions (% of total fuel combustion) of World in 1990 to that in 1995?
Offer a terse response. 1.05. What is the ratio of the CO2 emissions (% of total fuel combustion) of Malta in 1990 to that in 1995?
Keep it short and to the point. 0.84. What is the ratio of the CO2 emissions (% of total fuel combustion) of Mauritius in 1990 to that in 1995?
Your response must be concise. 1.33. What is the ratio of the CO2 emissions (% of total fuel combustion) of Mongolia in 1990 to that in 1995?
Your response must be concise. 2.14. What is the ratio of the CO2 emissions (% of total fuel combustion) of World in 1990 to that in 1996?
Ensure brevity in your answer.  1.09. What is the ratio of the CO2 emissions (% of total fuel combustion) of Malta in 1990 to that in 1996?
Your answer should be compact. 0.82. What is the ratio of the CO2 emissions (% of total fuel combustion) of Mauritius in 1990 to that in 1996?
Offer a very short reply. 1.28. What is the ratio of the CO2 emissions (% of total fuel combustion) in Mongolia in 1990 to that in 1996?
Provide a succinct answer. 2.36. What is the ratio of the CO2 emissions (% of total fuel combustion) in World in 1991 to that in 1992?
Provide a short and direct response. 1.04. What is the ratio of the CO2 emissions (% of total fuel combustion) in Malta in 1991 to that in 1992?
Your response must be concise. 0.88. What is the ratio of the CO2 emissions (% of total fuel combustion) in Mauritius in 1991 to that in 1992?
Provide a short and direct response. 1.06. What is the ratio of the CO2 emissions (% of total fuel combustion) of Mongolia in 1991 to that in 1992?
Provide a succinct answer. 2.89. What is the ratio of the CO2 emissions (% of total fuel combustion) of World in 1991 to that in 1993?
Your answer should be compact. 1.02. What is the ratio of the CO2 emissions (% of total fuel combustion) of Malta in 1991 to that in 1993?
Give a very brief answer. 1.14. What is the ratio of the CO2 emissions (% of total fuel combustion) in Mauritius in 1991 to that in 1993?
Your answer should be very brief. 1.08. What is the ratio of the CO2 emissions (% of total fuel combustion) of Mongolia in 1991 to that in 1993?
Provide a short and direct response. 1.6. What is the ratio of the CO2 emissions (% of total fuel combustion) in World in 1991 to that in 1994?
Offer a very short reply. 1.06. What is the ratio of the CO2 emissions (% of total fuel combustion) in Malta in 1991 to that in 1994?
Ensure brevity in your answer.  1.02. What is the ratio of the CO2 emissions (% of total fuel combustion) of Mauritius in 1991 to that in 1994?
Give a very brief answer. 1.21. What is the ratio of the CO2 emissions (% of total fuel combustion) in Mongolia in 1991 to that in 1994?
Offer a very short reply. 1.39. What is the ratio of the CO2 emissions (% of total fuel combustion) in World in 1991 to that in 1995?
Your answer should be very brief. 1.05. What is the ratio of the CO2 emissions (% of total fuel combustion) of Malta in 1991 to that in 1995?
Your answer should be very brief. 0.88. What is the ratio of the CO2 emissions (% of total fuel combustion) of Mauritius in 1991 to that in 1995?
Your answer should be very brief. 1.23. What is the ratio of the CO2 emissions (% of total fuel combustion) in Mongolia in 1991 to that in 1995?
Offer a very short reply. 3.69. What is the ratio of the CO2 emissions (% of total fuel combustion) in World in 1991 to that in 1996?
Keep it short and to the point. 1.09. What is the ratio of the CO2 emissions (% of total fuel combustion) in Malta in 1991 to that in 1996?
Offer a very short reply. 0.86. What is the ratio of the CO2 emissions (% of total fuel combustion) of Mauritius in 1991 to that in 1996?
Offer a terse response. 1.19. What is the ratio of the CO2 emissions (% of total fuel combustion) in Mongolia in 1991 to that in 1996?
Make the answer very short. 4.08. What is the ratio of the CO2 emissions (% of total fuel combustion) in World in 1992 to that in 1993?
Provide a short and direct response. 0.98. What is the ratio of the CO2 emissions (% of total fuel combustion) of Malta in 1992 to that in 1993?
Keep it short and to the point. 1.29. What is the ratio of the CO2 emissions (% of total fuel combustion) of Mauritius in 1992 to that in 1993?
Ensure brevity in your answer.  1.02. What is the ratio of the CO2 emissions (% of total fuel combustion) of Mongolia in 1992 to that in 1993?
Keep it short and to the point. 0.55. What is the ratio of the CO2 emissions (% of total fuel combustion) in World in 1992 to that in 1994?
Make the answer very short. 1.02. What is the ratio of the CO2 emissions (% of total fuel combustion) in Malta in 1992 to that in 1994?
Offer a very short reply. 1.16. What is the ratio of the CO2 emissions (% of total fuel combustion) of Mauritius in 1992 to that in 1994?
Make the answer very short. 1.15. What is the ratio of the CO2 emissions (% of total fuel combustion) in Mongolia in 1992 to that in 1994?
Offer a terse response. 0.48. What is the ratio of the CO2 emissions (% of total fuel combustion) of World in 1992 to that in 1995?
Your answer should be very brief. 1.01. What is the ratio of the CO2 emissions (% of total fuel combustion) of Malta in 1992 to that in 1995?
Give a very brief answer. 1. What is the ratio of the CO2 emissions (% of total fuel combustion) of Mauritius in 1992 to that in 1995?
Offer a terse response. 1.17. What is the ratio of the CO2 emissions (% of total fuel combustion) in Mongolia in 1992 to that in 1995?
Ensure brevity in your answer.  1.28. What is the ratio of the CO2 emissions (% of total fuel combustion) of World in 1992 to that in 1996?
Ensure brevity in your answer.  1.06. What is the ratio of the CO2 emissions (% of total fuel combustion) of Malta in 1992 to that in 1996?
Offer a terse response. 0.98. What is the ratio of the CO2 emissions (% of total fuel combustion) in Mauritius in 1992 to that in 1996?
Your response must be concise. 1.13. What is the ratio of the CO2 emissions (% of total fuel combustion) in Mongolia in 1992 to that in 1996?
Offer a terse response. 1.41. What is the ratio of the CO2 emissions (% of total fuel combustion) of World in 1993 to that in 1994?
Keep it short and to the point. 1.04. What is the ratio of the CO2 emissions (% of total fuel combustion) of Malta in 1993 to that in 1994?
Give a very brief answer. 0.9. What is the ratio of the CO2 emissions (% of total fuel combustion) of Mauritius in 1993 to that in 1994?
Your answer should be very brief. 1.12. What is the ratio of the CO2 emissions (% of total fuel combustion) of Mongolia in 1993 to that in 1994?
Keep it short and to the point. 0.87. What is the ratio of the CO2 emissions (% of total fuel combustion) in World in 1993 to that in 1995?
Provide a short and direct response. 1.03. What is the ratio of the CO2 emissions (% of total fuel combustion) in Malta in 1993 to that in 1995?
Keep it short and to the point. 0.77. What is the ratio of the CO2 emissions (% of total fuel combustion) of Mauritius in 1993 to that in 1995?
Offer a very short reply. 1.14. What is the ratio of the CO2 emissions (% of total fuel combustion) in Mongolia in 1993 to that in 1995?
Offer a very short reply. 2.3. What is the ratio of the CO2 emissions (% of total fuel combustion) of World in 1993 to that in 1996?
Your answer should be compact. 1.08. What is the ratio of the CO2 emissions (% of total fuel combustion) in Malta in 1993 to that in 1996?
Your answer should be very brief. 0.75. What is the ratio of the CO2 emissions (% of total fuel combustion) of Mauritius in 1993 to that in 1996?
Provide a succinct answer. 1.1. What is the ratio of the CO2 emissions (% of total fuel combustion) of Mongolia in 1993 to that in 1996?
Make the answer very short. 2.54. What is the ratio of the CO2 emissions (% of total fuel combustion) of Malta in 1994 to that in 1995?
Provide a succinct answer. 0.86. What is the ratio of the CO2 emissions (% of total fuel combustion) of Mongolia in 1994 to that in 1995?
Provide a short and direct response. 2.65. What is the ratio of the CO2 emissions (% of total fuel combustion) of World in 1994 to that in 1996?
Offer a terse response. 1.04. What is the ratio of the CO2 emissions (% of total fuel combustion) in Malta in 1994 to that in 1996?
Make the answer very short. 0.84. What is the ratio of the CO2 emissions (% of total fuel combustion) in Mauritius in 1994 to that in 1996?
Provide a succinct answer. 0.98. What is the ratio of the CO2 emissions (% of total fuel combustion) of Mongolia in 1994 to that in 1996?
Make the answer very short. 2.92. What is the ratio of the CO2 emissions (% of total fuel combustion) in World in 1995 to that in 1996?
Offer a terse response. 1.04. What is the ratio of the CO2 emissions (% of total fuel combustion) in Malta in 1995 to that in 1996?
Your response must be concise. 0.98. What is the ratio of the CO2 emissions (% of total fuel combustion) of Mauritius in 1995 to that in 1996?
Make the answer very short. 0.97. What is the ratio of the CO2 emissions (% of total fuel combustion) in Mongolia in 1995 to that in 1996?
Your answer should be very brief. 1.1. What is the difference between the highest and the second highest CO2 emissions (% of total fuel combustion) of World?
Provide a succinct answer. 0.03. What is the difference between the highest and the second highest CO2 emissions (% of total fuel combustion) in Malta?
Your answer should be compact. 0.1. What is the difference between the highest and the second highest CO2 emissions (% of total fuel combustion) of Mauritius?
Make the answer very short. 0.76. What is the difference between the highest and the second highest CO2 emissions (% of total fuel combustion) in Mongolia?
Give a very brief answer. 3.12. What is the difference between the highest and the lowest CO2 emissions (% of total fuel combustion) in World?
Provide a short and direct response. 1.1. What is the difference between the highest and the lowest CO2 emissions (% of total fuel combustion) in Malta?
Your answer should be very brief. 1.17. What is the difference between the highest and the lowest CO2 emissions (% of total fuel combustion) of Mauritius?
Your response must be concise. 2.59. What is the difference between the highest and the lowest CO2 emissions (% of total fuel combustion) of Mongolia?
Offer a terse response. 8.32. 